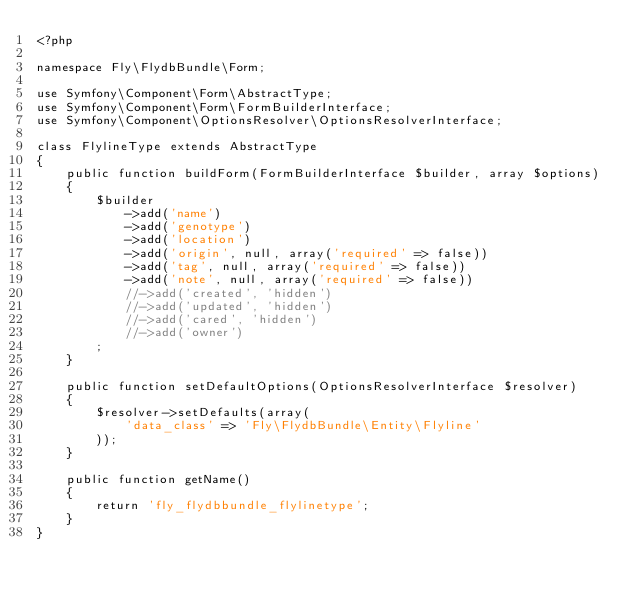Convert code to text. <code><loc_0><loc_0><loc_500><loc_500><_PHP_><?php

namespace Fly\FlydbBundle\Form;

use Symfony\Component\Form\AbstractType;
use Symfony\Component\Form\FormBuilderInterface;
use Symfony\Component\OptionsResolver\OptionsResolverInterface;

class FlylineType extends AbstractType
{
    public function buildForm(FormBuilderInterface $builder, array $options)
    {
        $builder
            ->add('name')
            ->add('genotype')
            ->add('location')
            ->add('origin', null, array('required' => false))
            ->add('tag', null, array('required' => false))
            ->add('note', null, array('required' => false))
            //->add('created', 'hidden')
            //->add('updated', 'hidden')
            //->add('cared', 'hidden')
            //->add('owner')
        ;
    }

    public function setDefaultOptions(OptionsResolverInterface $resolver)
    {
        $resolver->setDefaults(array(
            'data_class' => 'Fly\FlydbBundle\Entity\Flyline'
        ));
    }

    public function getName()
    {
        return 'fly_flydbbundle_flylinetype';
    }
}
</code> 